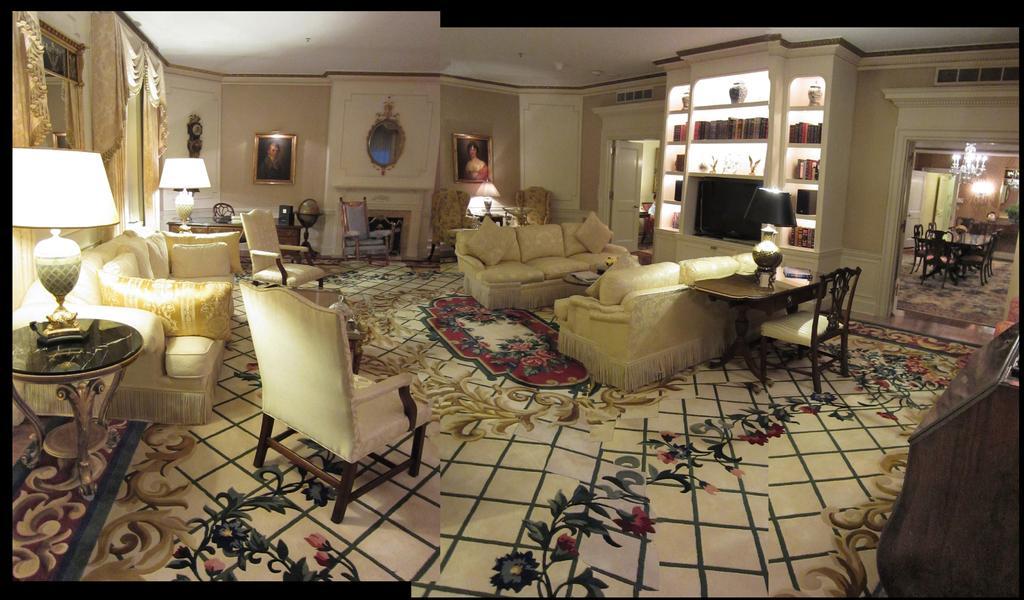Describe this image in one or two sentences. This is completely an inside view picture. Here we can see few empty chairs and sofas and pillows and cushions. This is a cupboard where books and pots are arranged in it. Here we can see photo frames over a wall. These are curtains. We can see a table lamp on the table. Here we can see a dining table in another room and this is a ceiling light, AC ducts. 